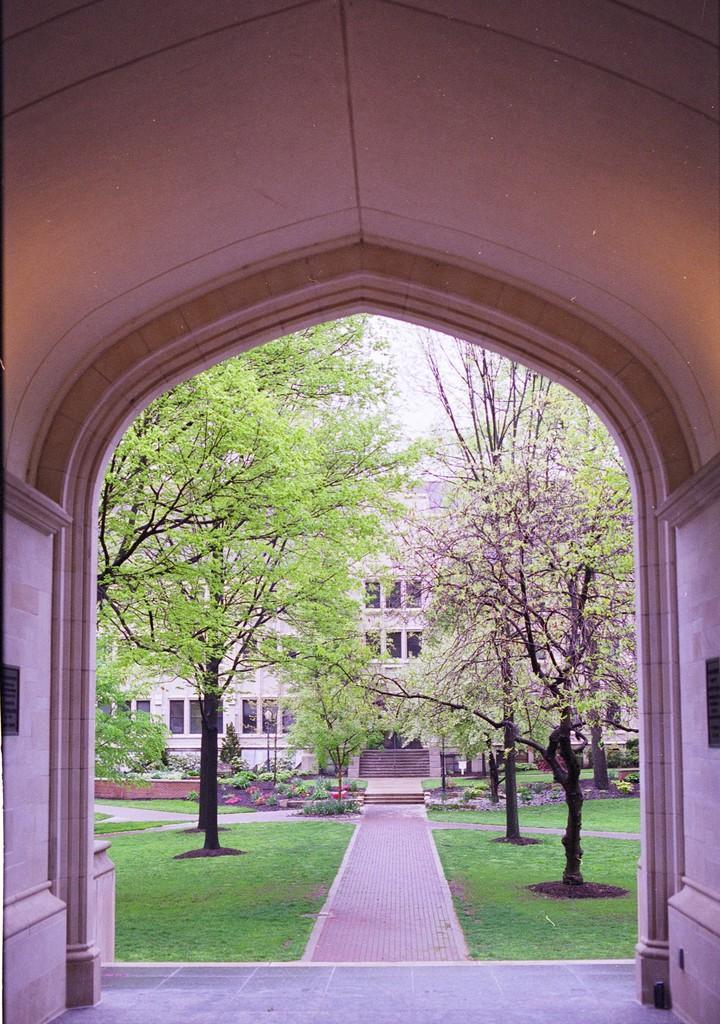Could you give a brief overview of what you see in this image? In the image there is an arch, behind the arch there is a path and around the path there is grass, trees, plants and in the background there is a building. 